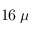<formula> <loc_0><loc_0><loc_500><loc_500>1 6 \, \mu</formula> 